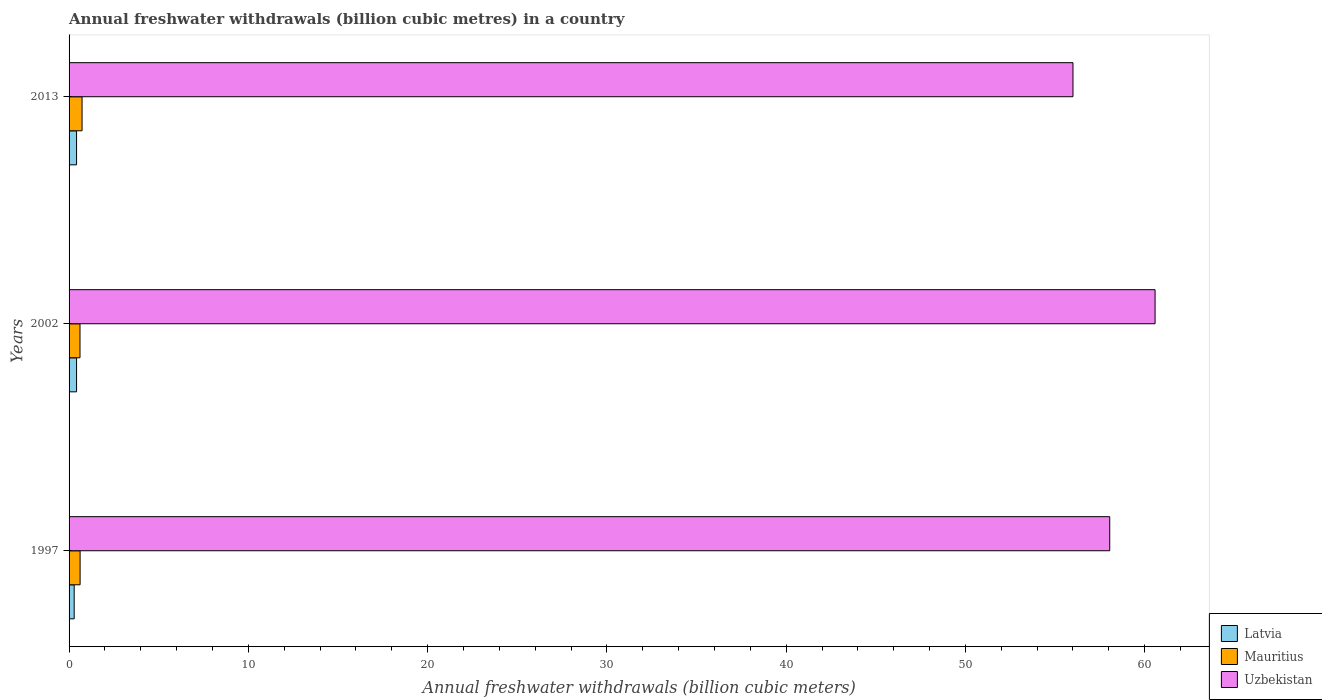How many groups of bars are there?
Provide a succinct answer. 3. Are the number of bars per tick equal to the number of legend labels?
Keep it short and to the point. Yes. Are the number of bars on each tick of the Y-axis equal?
Your answer should be very brief. Yes. How many bars are there on the 1st tick from the bottom?
Your answer should be very brief. 3. What is the annual freshwater withdrawals in Mauritius in 1997?
Make the answer very short. 0.61. Across all years, what is the maximum annual freshwater withdrawals in Latvia?
Keep it short and to the point. 0.42. Across all years, what is the minimum annual freshwater withdrawals in Uzbekistan?
Give a very brief answer. 56. In which year was the annual freshwater withdrawals in Uzbekistan minimum?
Keep it short and to the point. 2013. What is the total annual freshwater withdrawals in Mauritius in the graph?
Your answer should be compact. 1.95. What is the difference between the annual freshwater withdrawals in Uzbekistan in 1997 and that in 2002?
Make the answer very short. -2.53. What is the difference between the annual freshwater withdrawals in Mauritius in 1997 and the annual freshwater withdrawals in Uzbekistan in 2002?
Ensure brevity in your answer.  -59.96. What is the average annual freshwater withdrawals in Mauritius per year?
Offer a terse response. 0.65. In the year 2013, what is the difference between the annual freshwater withdrawals in Uzbekistan and annual freshwater withdrawals in Mauritius?
Make the answer very short. 55.27. In how many years, is the annual freshwater withdrawals in Mauritius greater than 22 billion cubic meters?
Provide a short and direct response. 0. What is the ratio of the annual freshwater withdrawals in Mauritius in 1997 to that in 2002?
Keep it short and to the point. 1.01. Is the annual freshwater withdrawals in Mauritius in 2002 less than that in 2013?
Keep it short and to the point. Yes. Is the difference between the annual freshwater withdrawals in Uzbekistan in 1997 and 2013 greater than the difference between the annual freshwater withdrawals in Mauritius in 1997 and 2013?
Give a very brief answer. Yes. What is the difference between the highest and the lowest annual freshwater withdrawals in Uzbekistan?
Your answer should be very brief. 4.58. In how many years, is the annual freshwater withdrawals in Latvia greater than the average annual freshwater withdrawals in Latvia taken over all years?
Keep it short and to the point. 2. What does the 1st bar from the top in 2002 represents?
Offer a very short reply. Uzbekistan. What does the 2nd bar from the bottom in 1997 represents?
Your response must be concise. Mauritius. Is it the case that in every year, the sum of the annual freshwater withdrawals in Latvia and annual freshwater withdrawals in Mauritius is greater than the annual freshwater withdrawals in Uzbekistan?
Keep it short and to the point. No. What is the difference between two consecutive major ticks on the X-axis?
Offer a very short reply. 10. Does the graph contain grids?
Keep it short and to the point. No. Where does the legend appear in the graph?
Make the answer very short. Bottom right. How many legend labels are there?
Give a very brief answer. 3. What is the title of the graph?
Your response must be concise. Annual freshwater withdrawals (billion cubic metres) in a country. What is the label or title of the X-axis?
Your response must be concise. Annual freshwater withdrawals (billion cubic meters). What is the Annual freshwater withdrawals (billion cubic meters) of Latvia in 1997?
Keep it short and to the point. 0.28. What is the Annual freshwater withdrawals (billion cubic meters) of Mauritius in 1997?
Give a very brief answer. 0.61. What is the Annual freshwater withdrawals (billion cubic meters) of Uzbekistan in 1997?
Give a very brief answer. 58.05. What is the Annual freshwater withdrawals (billion cubic meters) of Latvia in 2002?
Provide a succinct answer. 0.42. What is the Annual freshwater withdrawals (billion cubic meters) of Mauritius in 2002?
Make the answer very short. 0.61. What is the Annual freshwater withdrawals (billion cubic meters) in Uzbekistan in 2002?
Make the answer very short. 60.58. What is the Annual freshwater withdrawals (billion cubic meters) of Latvia in 2013?
Keep it short and to the point. 0.42. What is the Annual freshwater withdrawals (billion cubic meters) in Mauritius in 2013?
Offer a very short reply. 0.72. What is the Annual freshwater withdrawals (billion cubic meters) of Uzbekistan in 2013?
Your answer should be compact. 56. Across all years, what is the maximum Annual freshwater withdrawals (billion cubic meters) of Latvia?
Your answer should be very brief. 0.42. Across all years, what is the maximum Annual freshwater withdrawals (billion cubic meters) in Mauritius?
Provide a short and direct response. 0.72. Across all years, what is the maximum Annual freshwater withdrawals (billion cubic meters) in Uzbekistan?
Ensure brevity in your answer.  60.58. Across all years, what is the minimum Annual freshwater withdrawals (billion cubic meters) of Latvia?
Ensure brevity in your answer.  0.28. Across all years, what is the minimum Annual freshwater withdrawals (billion cubic meters) in Mauritius?
Offer a terse response. 0.61. What is the total Annual freshwater withdrawals (billion cubic meters) in Latvia in the graph?
Make the answer very short. 1.12. What is the total Annual freshwater withdrawals (billion cubic meters) of Mauritius in the graph?
Make the answer very short. 1.95. What is the total Annual freshwater withdrawals (billion cubic meters) of Uzbekistan in the graph?
Give a very brief answer. 174.63. What is the difference between the Annual freshwater withdrawals (billion cubic meters) of Latvia in 1997 and that in 2002?
Offer a terse response. -0.13. What is the difference between the Annual freshwater withdrawals (billion cubic meters) of Mauritius in 1997 and that in 2002?
Keep it short and to the point. 0.01. What is the difference between the Annual freshwater withdrawals (billion cubic meters) in Uzbekistan in 1997 and that in 2002?
Ensure brevity in your answer.  -2.53. What is the difference between the Annual freshwater withdrawals (billion cubic meters) of Latvia in 1997 and that in 2013?
Your response must be concise. -0.13. What is the difference between the Annual freshwater withdrawals (billion cubic meters) in Mauritius in 1997 and that in 2013?
Your answer should be very brief. -0.11. What is the difference between the Annual freshwater withdrawals (billion cubic meters) in Uzbekistan in 1997 and that in 2013?
Your answer should be compact. 2.05. What is the difference between the Annual freshwater withdrawals (billion cubic meters) of Latvia in 2002 and that in 2013?
Ensure brevity in your answer.  0. What is the difference between the Annual freshwater withdrawals (billion cubic meters) of Mauritius in 2002 and that in 2013?
Your answer should be very brief. -0.12. What is the difference between the Annual freshwater withdrawals (billion cubic meters) in Uzbekistan in 2002 and that in 2013?
Offer a terse response. 4.58. What is the difference between the Annual freshwater withdrawals (billion cubic meters) of Latvia in 1997 and the Annual freshwater withdrawals (billion cubic meters) of Mauritius in 2002?
Your answer should be very brief. -0.33. What is the difference between the Annual freshwater withdrawals (billion cubic meters) in Latvia in 1997 and the Annual freshwater withdrawals (billion cubic meters) in Uzbekistan in 2002?
Your answer should be very brief. -60.3. What is the difference between the Annual freshwater withdrawals (billion cubic meters) of Mauritius in 1997 and the Annual freshwater withdrawals (billion cubic meters) of Uzbekistan in 2002?
Your response must be concise. -59.97. What is the difference between the Annual freshwater withdrawals (billion cubic meters) of Latvia in 1997 and the Annual freshwater withdrawals (billion cubic meters) of Mauritius in 2013?
Your answer should be compact. -0.44. What is the difference between the Annual freshwater withdrawals (billion cubic meters) of Latvia in 1997 and the Annual freshwater withdrawals (billion cubic meters) of Uzbekistan in 2013?
Provide a succinct answer. -55.72. What is the difference between the Annual freshwater withdrawals (billion cubic meters) of Mauritius in 1997 and the Annual freshwater withdrawals (billion cubic meters) of Uzbekistan in 2013?
Offer a very short reply. -55.38. What is the difference between the Annual freshwater withdrawals (billion cubic meters) of Latvia in 2002 and the Annual freshwater withdrawals (billion cubic meters) of Mauritius in 2013?
Your response must be concise. -0.31. What is the difference between the Annual freshwater withdrawals (billion cubic meters) in Latvia in 2002 and the Annual freshwater withdrawals (billion cubic meters) in Uzbekistan in 2013?
Your answer should be compact. -55.58. What is the difference between the Annual freshwater withdrawals (billion cubic meters) in Mauritius in 2002 and the Annual freshwater withdrawals (billion cubic meters) in Uzbekistan in 2013?
Your answer should be compact. -55.39. What is the average Annual freshwater withdrawals (billion cubic meters) of Latvia per year?
Make the answer very short. 0.37. What is the average Annual freshwater withdrawals (billion cubic meters) of Mauritius per year?
Give a very brief answer. 0.65. What is the average Annual freshwater withdrawals (billion cubic meters) of Uzbekistan per year?
Ensure brevity in your answer.  58.21. In the year 1997, what is the difference between the Annual freshwater withdrawals (billion cubic meters) in Latvia and Annual freshwater withdrawals (billion cubic meters) in Mauritius?
Your response must be concise. -0.33. In the year 1997, what is the difference between the Annual freshwater withdrawals (billion cubic meters) in Latvia and Annual freshwater withdrawals (billion cubic meters) in Uzbekistan?
Provide a short and direct response. -57.77. In the year 1997, what is the difference between the Annual freshwater withdrawals (billion cubic meters) of Mauritius and Annual freshwater withdrawals (billion cubic meters) of Uzbekistan?
Your response must be concise. -57.44. In the year 2002, what is the difference between the Annual freshwater withdrawals (billion cubic meters) of Latvia and Annual freshwater withdrawals (billion cubic meters) of Mauritius?
Offer a very short reply. -0.19. In the year 2002, what is the difference between the Annual freshwater withdrawals (billion cubic meters) of Latvia and Annual freshwater withdrawals (billion cubic meters) of Uzbekistan?
Provide a succinct answer. -60.16. In the year 2002, what is the difference between the Annual freshwater withdrawals (billion cubic meters) of Mauritius and Annual freshwater withdrawals (billion cubic meters) of Uzbekistan?
Offer a terse response. -59.97. In the year 2013, what is the difference between the Annual freshwater withdrawals (billion cubic meters) of Latvia and Annual freshwater withdrawals (billion cubic meters) of Mauritius?
Make the answer very short. -0.31. In the year 2013, what is the difference between the Annual freshwater withdrawals (billion cubic meters) in Latvia and Annual freshwater withdrawals (billion cubic meters) in Uzbekistan?
Keep it short and to the point. -55.58. In the year 2013, what is the difference between the Annual freshwater withdrawals (billion cubic meters) in Mauritius and Annual freshwater withdrawals (billion cubic meters) in Uzbekistan?
Your answer should be compact. -55.27. What is the ratio of the Annual freshwater withdrawals (billion cubic meters) of Latvia in 1997 to that in 2002?
Make the answer very short. 0.68. What is the ratio of the Annual freshwater withdrawals (billion cubic meters) of Mauritius in 1997 to that in 2002?
Provide a short and direct response. 1.01. What is the ratio of the Annual freshwater withdrawals (billion cubic meters) of Uzbekistan in 1997 to that in 2002?
Your answer should be very brief. 0.96. What is the ratio of the Annual freshwater withdrawals (billion cubic meters) of Latvia in 1997 to that in 2013?
Provide a succinct answer. 0.68. What is the ratio of the Annual freshwater withdrawals (billion cubic meters) in Mauritius in 1997 to that in 2013?
Your response must be concise. 0.85. What is the ratio of the Annual freshwater withdrawals (billion cubic meters) in Uzbekistan in 1997 to that in 2013?
Your response must be concise. 1.04. What is the ratio of the Annual freshwater withdrawals (billion cubic meters) of Latvia in 2002 to that in 2013?
Your answer should be very brief. 1. What is the ratio of the Annual freshwater withdrawals (billion cubic meters) in Mauritius in 2002 to that in 2013?
Your answer should be compact. 0.84. What is the ratio of the Annual freshwater withdrawals (billion cubic meters) in Uzbekistan in 2002 to that in 2013?
Provide a succinct answer. 1.08. What is the difference between the highest and the second highest Annual freshwater withdrawals (billion cubic meters) of Latvia?
Offer a very short reply. 0. What is the difference between the highest and the second highest Annual freshwater withdrawals (billion cubic meters) in Mauritius?
Ensure brevity in your answer.  0.11. What is the difference between the highest and the second highest Annual freshwater withdrawals (billion cubic meters) of Uzbekistan?
Your response must be concise. 2.53. What is the difference between the highest and the lowest Annual freshwater withdrawals (billion cubic meters) in Latvia?
Your response must be concise. 0.13. What is the difference between the highest and the lowest Annual freshwater withdrawals (billion cubic meters) in Mauritius?
Keep it short and to the point. 0.12. What is the difference between the highest and the lowest Annual freshwater withdrawals (billion cubic meters) of Uzbekistan?
Ensure brevity in your answer.  4.58. 